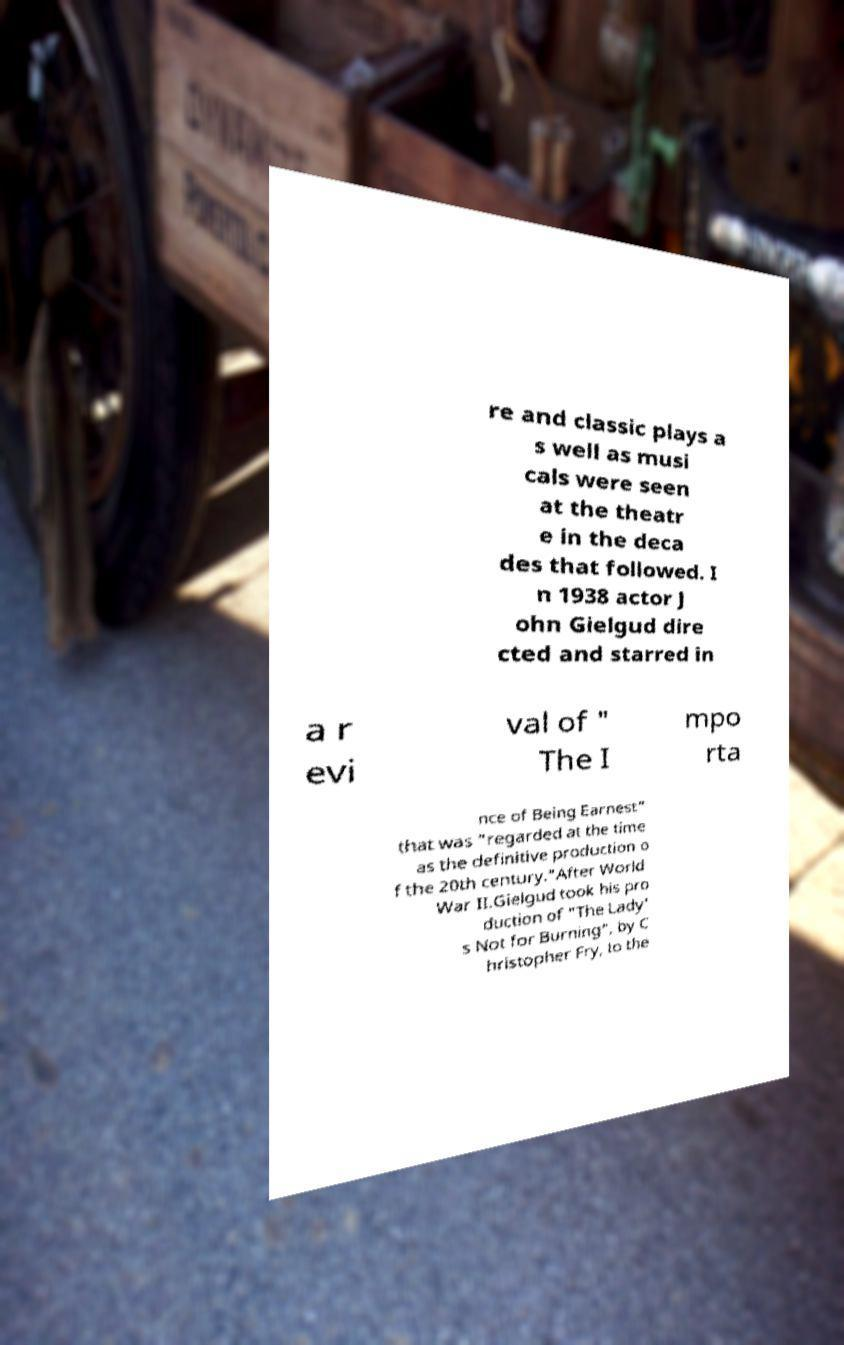Could you assist in decoding the text presented in this image and type it out clearly? re and classic plays a s well as musi cals were seen at the theatr e in the deca des that followed. I n 1938 actor J ohn Gielgud dire cted and starred in a r evi val of " The I mpo rta nce of Being Earnest" that was "regarded at the time as the definitive production o f the 20th century."After World War II.Gielgud took his pro duction of "The Lady' s Not for Burning", by C hristopher Fry, to the 